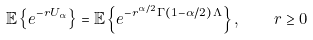<formula> <loc_0><loc_0><loc_500><loc_500>\mathbb { E } \left \{ e ^ { - r U _ { \alpha } } \right \} = \mathbb { E } \left \{ e ^ { - r ^ { \alpha / 2 } \Gamma ( 1 - \alpha / 2 ) \, \Lambda } \right \} , \quad r \geq 0</formula> 